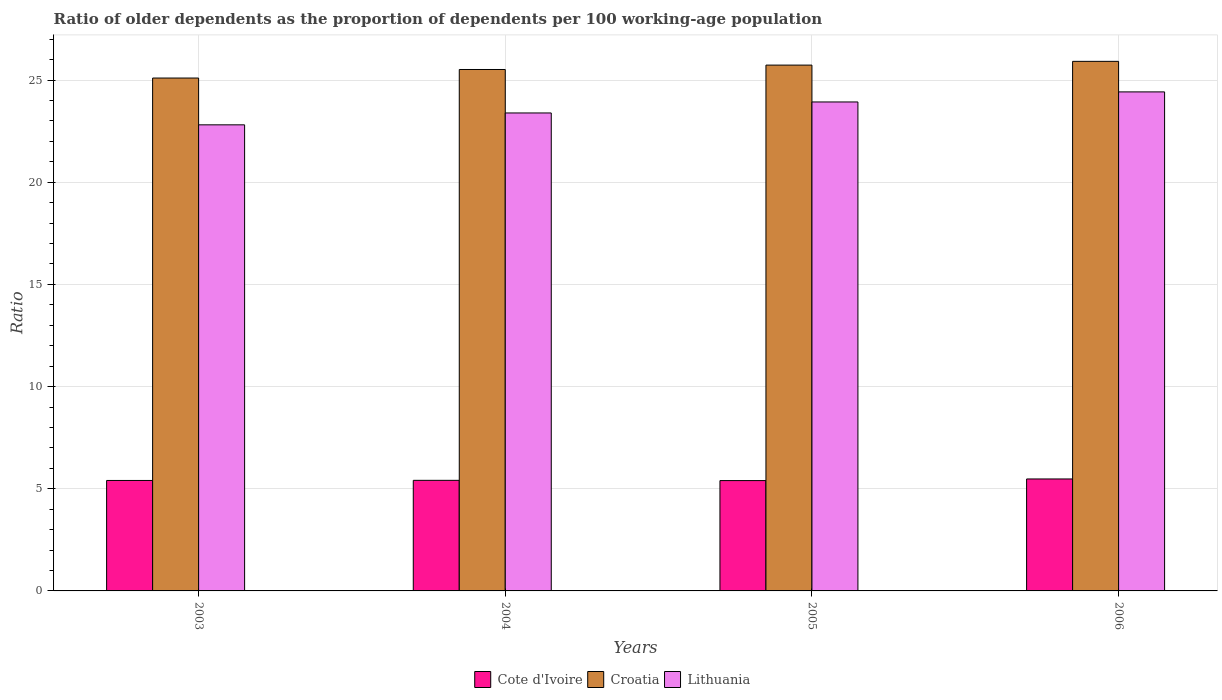How many different coloured bars are there?
Keep it short and to the point. 3. Are the number of bars per tick equal to the number of legend labels?
Your response must be concise. Yes. How many bars are there on the 3rd tick from the left?
Give a very brief answer. 3. How many bars are there on the 3rd tick from the right?
Your answer should be very brief. 3. What is the age dependency ratio(old) in Lithuania in 2005?
Your response must be concise. 23.93. Across all years, what is the maximum age dependency ratio(old) in Croatia?
Offer a terse response. 25.92. Across all years, what is the minimum age dependency ratio(old) in Cote d'Ivoire?
Your response must be concise. 5.4. In which year was the age dependency ratio(old) in Lithuania maximum?
Provide a succinct answer. 2006. What is the total age dependency ratio(old) in Croatia in the graph?
Keep it short and to the point. 102.27. What is the difference between the age dependency ratio(old) in Cote d'Ivoire in 2005 and that in 2006?
Your answer should be compact. -0.08. What is the difference between the age dependency ratio(old) in Lithuania in 2006 and the age dependency ratio(old) in Cote d'Ivoire in 2004?
Provide a succinct answer. 19.01. What is the average age dependency ratio(old) in Croatia per year?
Keep it short and to the point. 25.57. In the year 2003, what is the difference between the age dependency ratio(old) in Lithuania and age dependency ratio(old) in Croatia?
Keep it short and to the point. -2.29. In how many years, is the age dependency ratio(old) in Cote d'Ivoire greater than 21?
Provide a succinct answer. 0. What is the ratio of the age dependency ratio(old) in Croatia in 2003 to that in 2005?
Your response must be concise. 0.98. What is the difference between the highest and the second highest age dependency ratio(old) in Cote d'Ivoire?
Offer a very short reply. 0.07. What is the difference between the highest and the lowest age dependency ratio(old) in Croatia?
Your response must be concise. 0.82. Is the sum of the age dependency ratio(old) in Croatia in 2003 and 2005 greater than the maximum age dependency ratio(old) in Lithuania across all years?
Provide a succinct answer. Yes. What does the 3rd bar from the left in 2003 represents?
Give a very brief answer. Lithuania. What does the 1st bar from the right in 2006 represents?
Offer a terse response. Lithuania. How many bars are there?
Keep it short and to the point. 12. How many years are there in the graph?
Ensure brevity in your answer.  4. What is the difference between two consecutive major ticks on the Y-axis?
Offer a very short reply. 5. Are the values on the major ticks of Y-axis written in scientific E-notation?
Keep it short and to the point. No. Does the graph contain any zero values?
Provide a short and direct response. No. Where does the legend appear in the graph?
Your answer should be compact. Bottom center. How many legend labels are there?
Your response must be concise. 3. How are the legend labels stacked?
Give a very brief answer. Horizontal. What is the title of the graph?
Your answer should be very brief. Ratio of older dependents as the proportion of dependents per 100 working-age population. Does "Upper middle income" appear as one of the legend labels in the graph?
Your answer should be very brief. No. What is the label or title of the Y-axis?
Keep it short and to the point. Ratio. What is the Ratio of Cote d'Ivoire in 2003?
Provide a short and direct response. 5.41. What is the Ratio of Croatia in 2003?
Offer a very short reply. 25.1. What is the Ratio in Lithuania in 2003?
Provide a short and direct response. 22.81. What is the Ratio of Cote d'Ivoire in 2004?
Your response must be concise. 5.41. What is the Ratio of Croatia in 2004?
Your response must be concise. 25.52. What is the Ratio of Lithuania in 2004?
Your response must be concise. 23.39. What is the Ratio of Cote d'Ivoire in 2005?
Give a very brief answer. 5.4. What is the Ratio of Croatia in 2005?
Your answer should be very brief. 25.73. What is the Ratio in Lithuania in 2005?
Keep it short and to the point. 23.93. What is the Ratio of Cote d'Ivoire in 2006?
Your answer should be compact. 5.48. What is the Ratio of Croatia in 2006?
Offer a terse response. 25.92. What is the Ratio in Lithuania in 2006?
Provide a succinct answer. 24.42. Across all years, what is the maximum Ratio of Cote d'Ivoire?
Keep it short and to the point. 5.48. Across all years, what is the maximum Ratio in Croatia?
Provide a short and direct response. 25.92. Across all years, what is the maximum Ratio in Lithuania?
Keep it short and to the point. 24.42. Across all years, what is the minimum Ratio in Cote d'Ivoire?
Offer a very short reply. 5.4. Across all years, what is the minimum Ratio of Croatia?
Provide a short and direct response. 25.1. Across all years, what is the minimum Ratio in Lithuania?
Provide a short and direct response. 22.81. What is the total Ratio in Cote d'Ivoire in the graph?
Give a very brief answer. 21.7. What is the total Ratio in Croatia in the graph?
Offer a terse response. 102.27. What is the total Ratio in Lithuania in the graph?
Give a very brief answer. 94.55. What is the difference between the Ratio in Cote d'Ivoire in 2003 and that in 2004?
Give a very brief answer. -0.01. What is the difference between the Ratio of Croatia in 2003 and that in 2004?
Provide a succinct answer. -0.42. What is the difference between the Ratio of Lithuania in 2003 and that in 2004?
Provide a succinct answer. -0.58. What is the difference between the Ratio in Cote d'Ivoire in 2003 and that in 2005?
Your response must be concise. 0.01. What is the difference between the Ratio of Croatia in 2003 and that in 2005?
Your answer should be very brief. -0.63. What is the difference between the Ratio in Lithuania in 2003 and that in 2005?
Offer a terse response. -1.12. What is the difference between the Ratio of Cote d'Ivoire in 2003 and that in 2006?
Your answer should be very brief. -0.07. What is the difference between the Ratio of Croatia in 2003 and that in 2006?
Make the answer very short. -0.82. What is the difference between the Ratio of Lithuania in 2003 and that in 2006?
Your answer should be compact. -1.61. What is the difference between the Ratio in Cote d'Ivoire in 2004 and that in 2005?
Make the answer very short. 0.01. What is the difference between the Ratio in Croatia in 2004 and that in 2005?
Your response must be concise. -0.21. What is the difference between the Ratio of Lithuania in 2004 and that in 2005?
Ensure brevity in your answer.  -0.54. What is the difference between the Ratio in Cote d'Ivoire in 2004 and that in 2006?
Offer a terse response. -0.07. What is the difference between the Ratio in Croatia in 2004 and that in 2006?
Offer a very short reply. -0.4. What is the difference between the Ratio in Lithuania in 2004 and that in 2006?
Keep it short and to the point. -1.03. What is the difference between the Ratio in Cote d'Ivoire in 2005 and that in 2006?
Keep it short and to the point. -0.08. What is the difference between the Ratio of Croatia in 2005 and that in 2006?
Offer a very short reply. -0.18. What is the difference between the Ratio in Lithuania in 2005 and that in 2006?
Your answer should be compact. -0.49. What is the difference between the Ratio of Cote d'Ivoire in 2003 and the Ratio of Croatia in 2004?
Offer a terse response. -20.11. What is the difference between the Ratio of Cote d'Ivoire in 2003 and the Ratio of Lithuania in 2004?
Ensure brevity in your answer.  -17.99. What is the difference between the Ratio of Croatia in 2003 and the Ratio of Lithuania in 2004?
Make the answer very short. 1.71. What is the difference between the Ratio of Cote d'Ivoire in 2003 and the Ratio of Croatia in 2005?
Provide a short and direct response. -20.33. What is the difference between the Ratio in Cote d'Ivoire in 2003 and the Ratio in Lithuania in 2005?
Your answer should be very brief. -18.52. What is the difference between the Ratio of Croatia in 2003 and the Ratio of Lithuania in 2005?
Offer a very short reply. 1.17. What is the difference between the Ratio in Cote d'Ivoire in 2003 and the Ratio in Croatia in 2006?
Provide a short and direct response. -20.51. What is the difference between the Ratio of Cote d'Ivoire in 2003 and the Ratio of Lithuania in 2006?
Keep it short and to the point. -19.02. What is the difference between the Ratio of Croatia in 2003 and the Ratio of Lithuania in 2006?
Offer a very short reply. 0.68. What is the difference between the Ratio in Cote d'Ivoire in 2004 and the Ratio in Croatia in 2005?
Make the answer very short. -20.32. What is the difference between the Ratio of Cote d'Ivoire in 2004 and the Ratio of Lithuania in 2005?
Offer a terse response. -18.52. What is the difference between the Ratio in Croatia in 2004 and the Ratio in Lithuania in 2005?
Ensure brevity in your answer.  1.59. What is the difference between the Ratio in Cote d'Ivoire in 2004 and the Ratio in Croatia in 2006?
Offer a very short reply. -20.51. What is the difference between the Ratio of Cote d'Ivoire in 2004 and the Ratio of Lithuania in 2006?
Your answer should be compact. -19.01. What is the difference between the Ratio of Croatia in 2004 and the Ratio of Lithuania in 2006?
Provide a succinct answer. 1.1. What is the difference between the Ratio in Cote d'Ivoire in 2005 and the Ratio in Croatia in 2006?
Ensure brevity in your answer.  -20.52. What is the difference between the Ratio of Cote d'Ivoire in 2005 and the Ratio of Lithuania in 2006?
Your answer should be very brief. -19.02. What is the difference between the Ratio in Croatia in 2005 and the Ratio in Lithuania in 2006?
Give a very brief answer. 1.31. What is the average Ratio in Cote d'Ivoire per year?
Your response must be concise. 5.42. What is the average Ratio in Croatia per year?
Offer a terse response. 25.57. What is the average Ratio of Lithuania per year?
Ensure brevity in your answer.  23.64. In the year 2003, what is the difference between the Ratio of Cote d'Ivoire and Ratio of Croatia?
Make the answer very short. -19.69. In the year 2003, what is the difference between the Ratio of Cote d'Ivoire and Ratio of Lithuania?
Keep it short and to the point. -17.4. In the year 2003, what is the difference between the Ratio of Croatia and Ratio of Lithuania?
Make the answer very short. 2.29. In the year 2004, what is the difference between the Ratio in Cote d'Ivoire and Ratio in Croatia?
Your answer should be very brief. -20.11. In the year 2004, what is the difference between the Ratio of Cote d'Ivoire and Ratio of Lithuania?
Offer a very short reply. -17.98. In the year 2004, what is the difference between the Ratio in Croatia and Ratio in Lithuania?
Your response must be concise. 2.13. In the year 2005, what is the difference between the Ratio in Cote d'Ivoire and Ratio in Croatia?
Your answer should be compact. -20.33. In the year 2005, what is the difference between the Ratio of Cote d'Ivoire and Ratio of Lithuania?
Give a very brief answer. -18.53. In the year 2005, what is the difference between the Ratio of Croatia and Ratio of Lithuania?
Ensure brevity in your answer.  1.8. In the year 2006, what is the difference between the Ratio in Cote d'Ivoire and Ratio in Croatia?
Make the answer very short. -20.44. In the year 2006, what is the difference between the Ratio of Cote d'Ivoire and Ratio of Lithuania?
Give a very brief answer. -18.94. In the year 2006, what is the difference between the Ratio in Croatia and Ratio in Lithuania?
Offer a terse response. 1.49. What is the ratio of the Ratio in Cote d'Ivoire in 2003 to that in 2004?
Give a very brief answer. 1. What is the ratio of the Ratio of Croatia in 2003 to that in 2004?
Make the answer very short. 0.98. What is the ratio of the Ratio of Lithuania in 2003 to that in 2004?
Provide a succinct answer. 0.98. What is the ratio of the Ratio in Croatia in 2003 to that in 2005?
Your response must be concise. 0.98. What is the ratio of the Ratio of Lithuania in 2003 to that in 2005?
Provide a short and direct response. 0.95. What is the ratio of the Ratio of Cote d'Ivoire in 2003 to that in 2006?
Make the answer very short. 0.99. What is the ratio of the Ratio in Croatia in 2003 to that in 2006?
Provide a succinct answer. 0.97. What is the ratio of the Ratio of Lithuania in 2003 to that in 2006?
Your response must be concise. 0.93. What is the ratio of the Ratio in Cote d'Ivoire in 2004 to that in 2005?
Offer a terse response. 1. What is the ratio of the Ratio of Lithuania in 2004 to that in 2005?
Make the answer very short. 0.98. What is the ratio of the Ratio in Cote d'Ivoire in 2004 to that in 2006?
Offer a very short reply. 0.99. What is the ratio of the Ratio in Croatia in 2004 to that in 2006?
Give a very brief answer. 0.98. What is the ratio of the Ratio of Lithuania in 2004 to that in 2006?
Your answer should be compact. 0.96. What is the ratio of the Ratio of Cote d'Ivoire in 2005 to that in 2006?
Your answer should be very brief. 0.99. What is the ratio of the Ratio in Croatia in 2005 to that in 2006?
Your response must be concise. 0.99. What is the ratio of the Ratio of Lithuania in 2005 to that in 2006?
Give a very brief answer. 0.98. What is the difference between the highest and the second highest Ratio of Cote d'Ivoire?
Offer a terse response. 0.07. What is the difference between the highest and the second highest Ratio in Croatia?
Give a very brief answer. 0.18. What is the difference between the highest and the second highest Ratio of Lithuania?
Your answer should be very brief. 0.49. What is the difference between the highest and the lowest Ratio of Cote d'Ivoire?
Your response must be concise. 0.08. What is the difference between the highest and the lowest Ratio of Croatia?
Provide a short and direct response. 0.82. What is the difference between the highest and the lowest Ratio of Lithuania?
Provide a short and direct response. 1.61. 